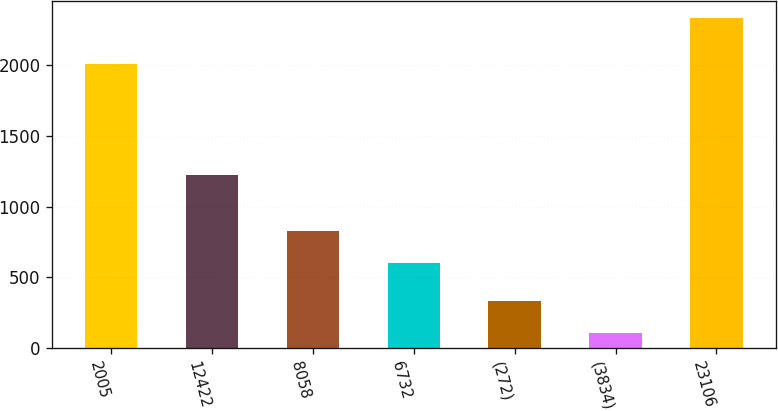Convert chart to OTSL. <chart><loc_0><loc_0><loc_500><loc_500><bar_chart><fcel>2005<fcel>12422<fcel>8058<fcel>6732<fcel>(272)<fcel>(3834)<fcel>23106<nl><fcel>2003<fcel>1221<fcel>825.17<fcel>602.8<fcel>330.27<fcel>107.9<fcel>2331.6<nl></chart> 